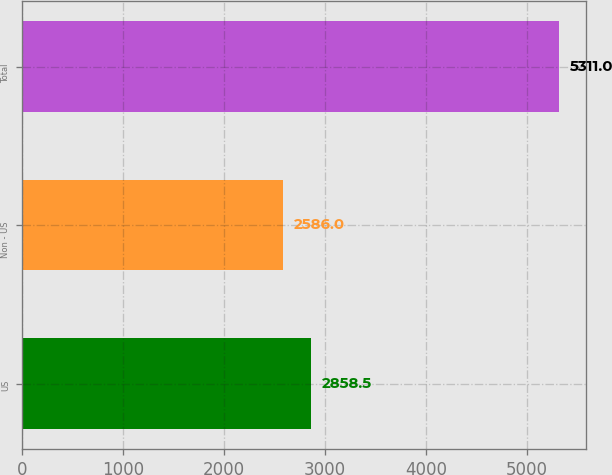<chart> <loc_0><loc_0><loc_500><loc_500><bar_chart><fcel>US<fcel>Non - US<fcel>Total<nl><fcel>2858.5<fcel>2586<fcel>5311<nl></chart> 